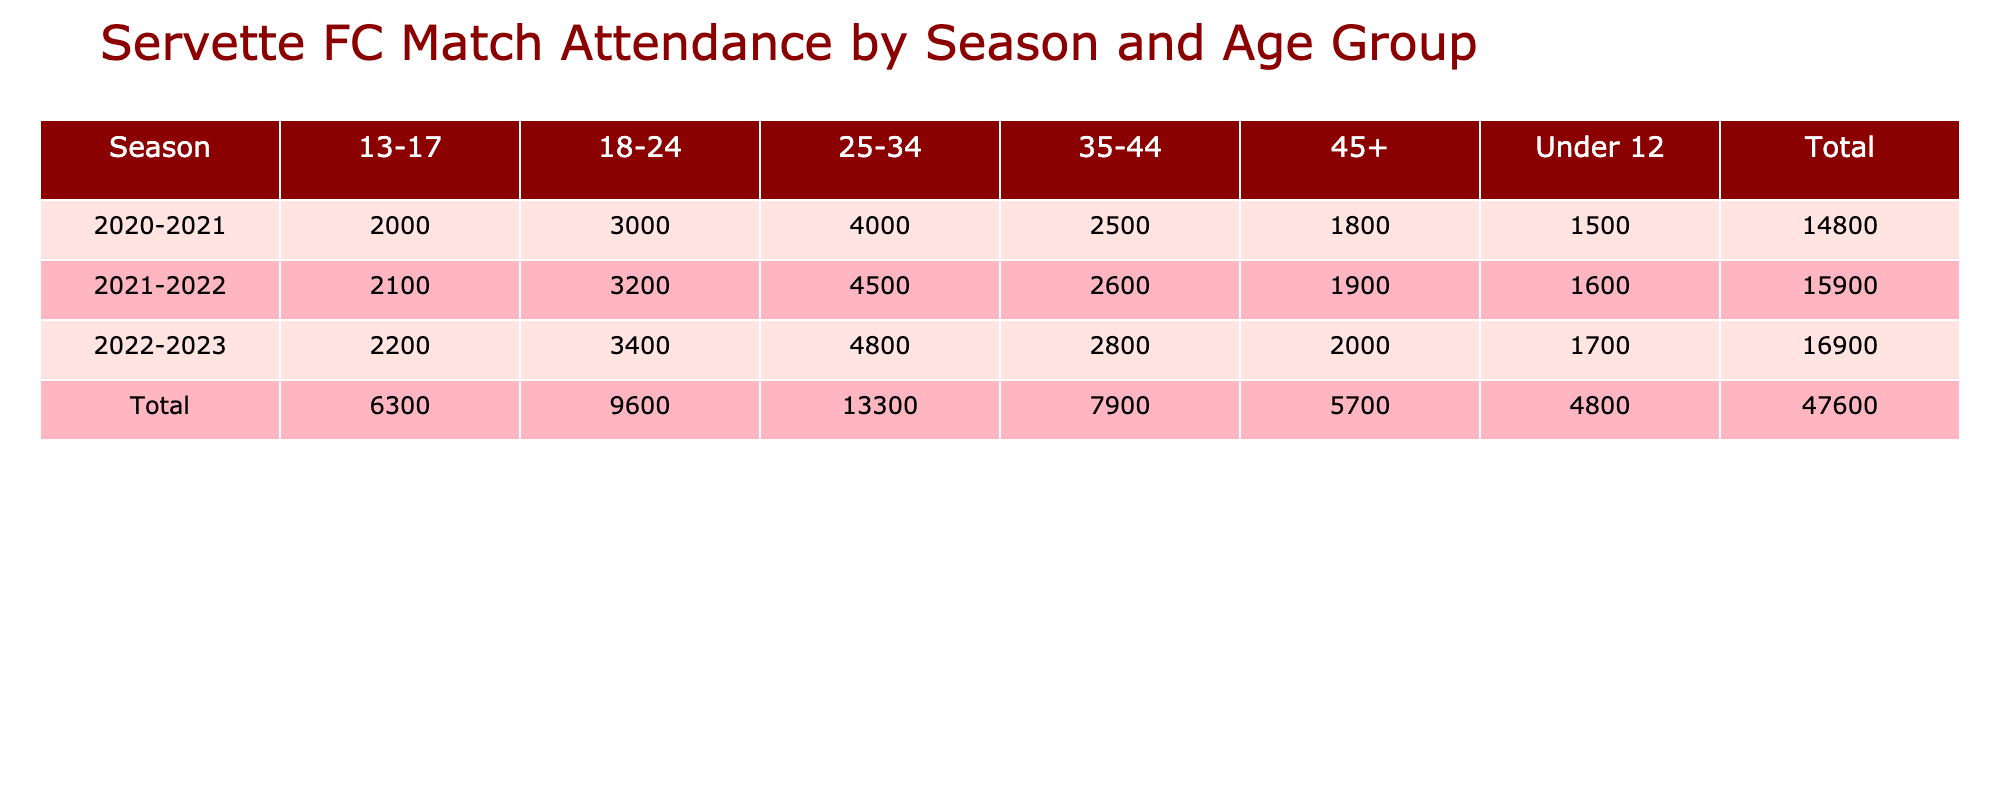What was the total attendance for the 2021-2022 season? To find the total attendance for the 2021-2022 season, look at the row corresponding to that season and sum the attendance values of all age groups: 1600 + 2100 + 3200 + 4500 + 2600 + 1900 = 18900.
Answer: 18900 Which age group had the highest attendance in the 2022-2023 season? In the 2022-2023 row, find the age group with the highest attendance: Under 12 (1700), 13-17 (2200), 18-24 (3400), 25-34 (4800), 35-44 (2800), and 45+ (2000). The highest is 25-34 with 4800 attendees.
Answer: 25-34 Did the attendance for the 35-44 age group increase from the 2020-2021 season to the 2022-2023 season? The attendance for the 35-44 age group in the 2020-2021 season was 2500, and in the 2022-2023 season it was 2800. Since 2800 > 2500, the attendance has increased.
Answer: Yes What is the average attendance for the 18-24 age group across all seasons? Calculate the average attendance for the 18-24 age group by summing the attendances for this group: 3000 (2020-2021) + 3200 (2021-2022) + 3400 (2022-2023) = 9600. Then divide by the number of seasons: 9600 / 3 = 3200.
Answer: 3200 In the 2020-2021 season, which age group had an attendance lower than 2500? Check the 2020-2021 row for age groups with attendance below 2500: Under 12 (1500), 13-17 (2000), 35-44 (2500), and 45+ (1800). The age groups below 2500 are Under 12, 13-17, and 45+.
Answer: Under 12, 13-17, 45+ 